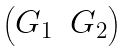<formula> <loc_0><loc_0><loc_500><loc_500>\begin{pmatrix} G _ { 1 } & G _ { 2 } \end{pmatrix}</formula> 